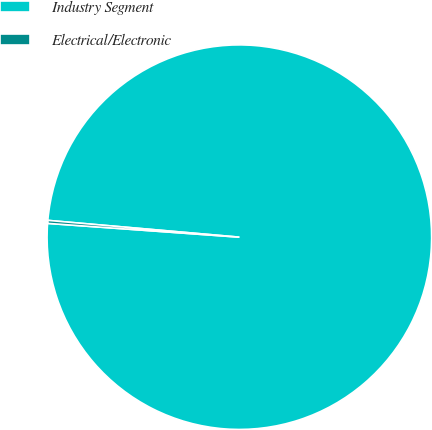<chart> <loc_0><loc_0><loc_500><loc_500><pie_chart><fcel>Industry Segment<fcel>Electrical/Electronic<nl><fcel>99.75%<fcel>0.25%<nl></chart> 